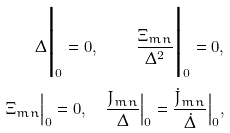Convert formula to latex. <formula><loc_0><loc_0><loc_500><loc_500>\Delta \Big | _ { 0 } = 0 , \quad \frac { \Xi { _ { m } } { _ { n } } } { \Delta ^ { 2 } } \Big | _ { 0 } = 0 , \\ \Xi { _ { m } } { _ { n } } \Big | _ { 0 } = 0 , \quad \frac { J { _ { m } } { _ { n } } } { \Delta } \Big | _ { 0 } = \frac { \dot { J } { _ { m } } { _ { n } } } { \dot { \Delta } } \Big | _ { 0 } ,</formula> 